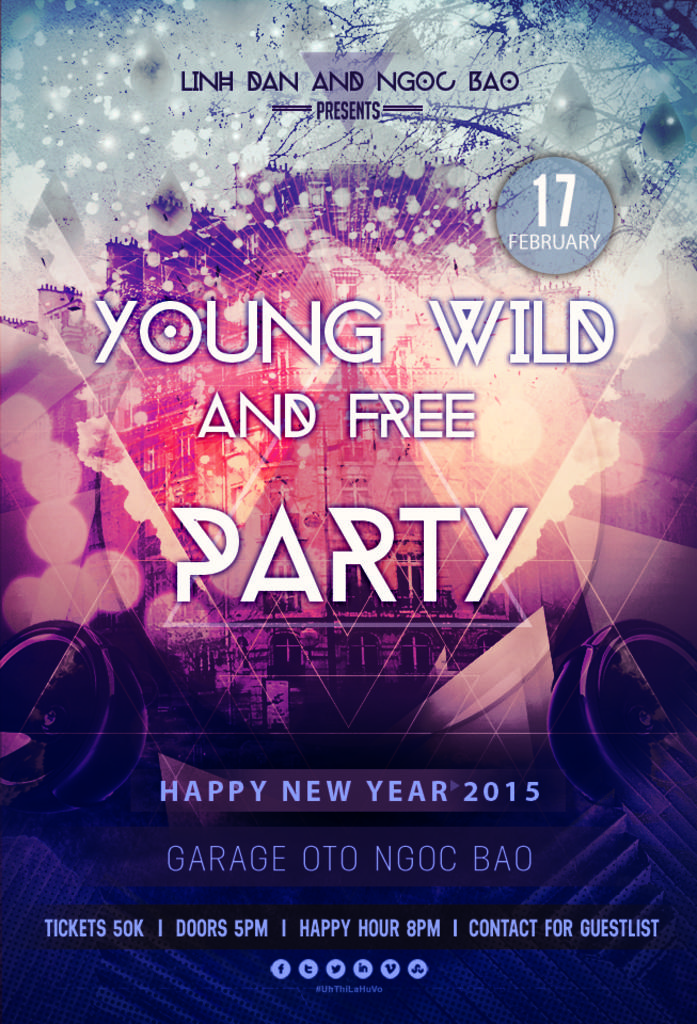When is the party?
Ensure brevity in your answer.  February 17th. Who is presenting this party?
Your answer should be very brief. Linh dan and ngoc bao. 